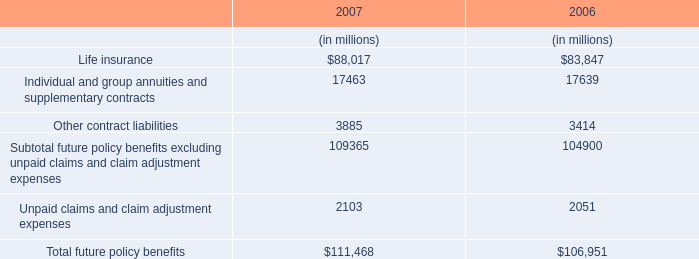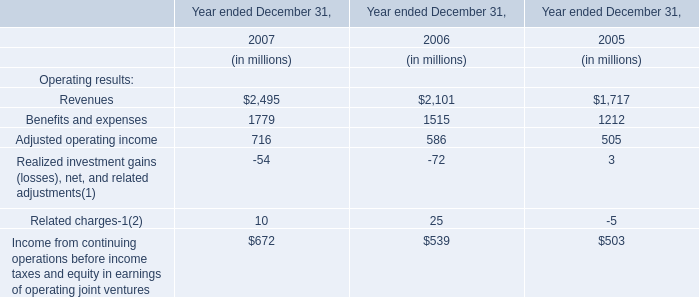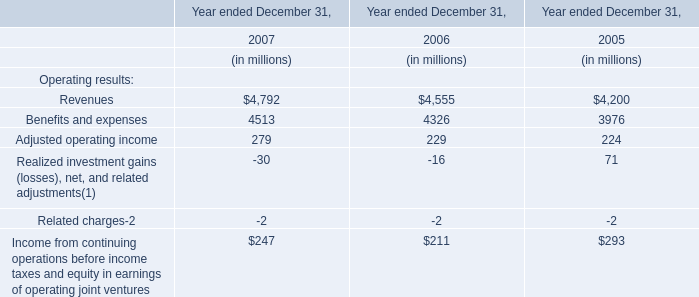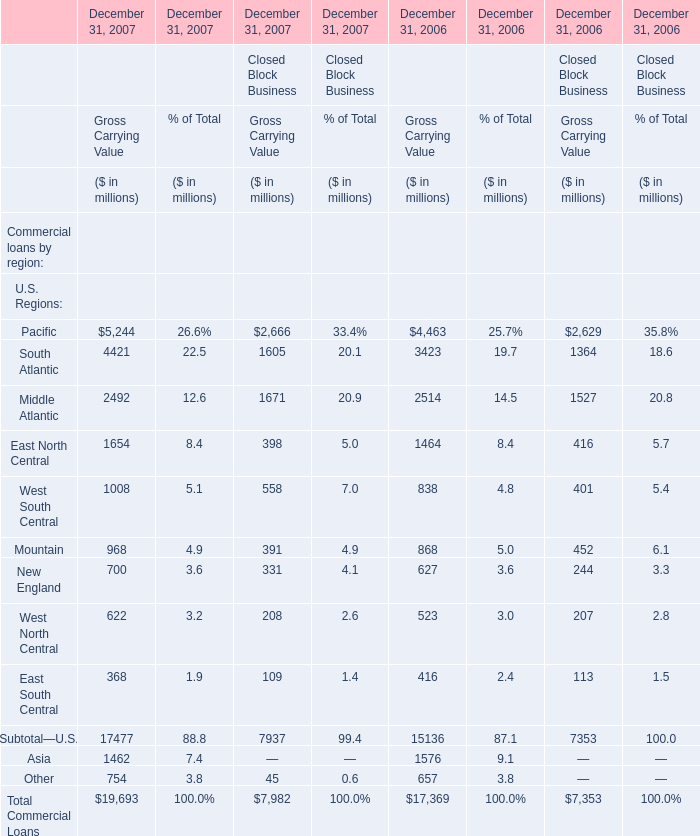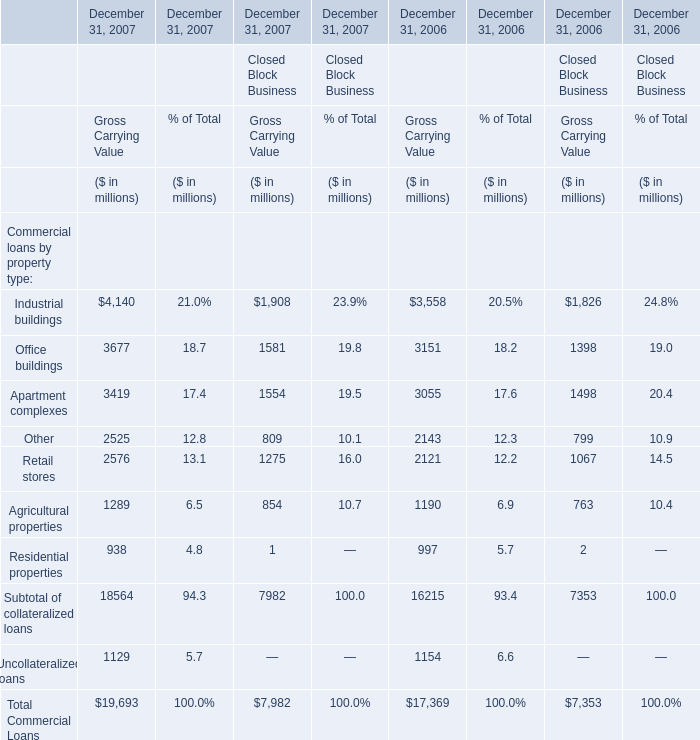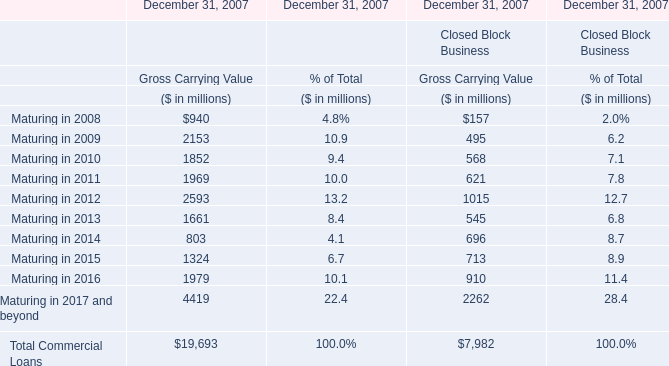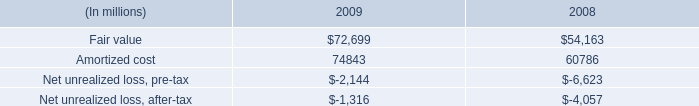what is the amortized cost as a percent of the fair value of the securities in 2009? 
Computations: (74843 / 72699)
Answer: 1.02949. 